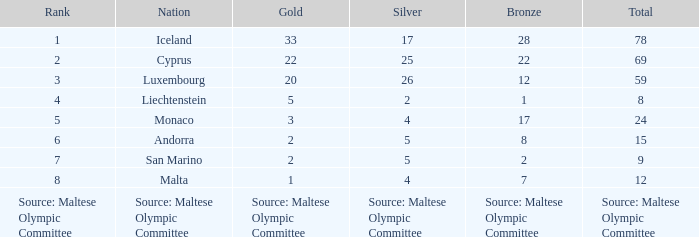When there are 8 bronze medals, how many gold medals are there? 2.0. 